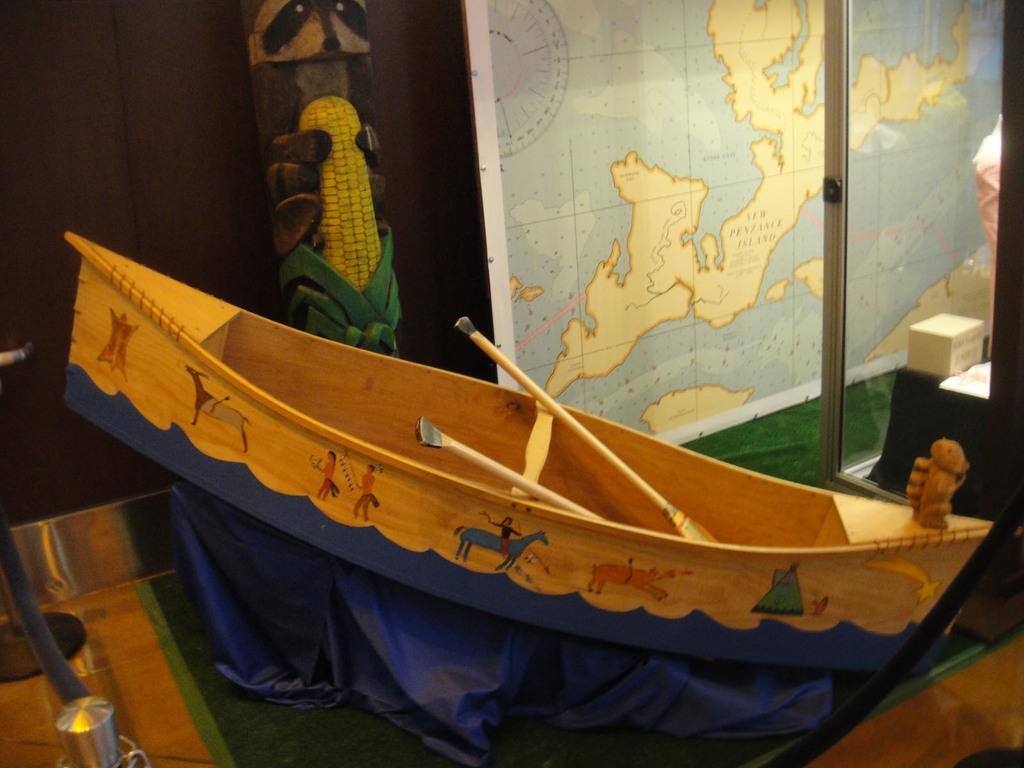What is depicted on the boat in the image? There is a painting on the boat in the image. What objects are used for propulsion in the image? There are paddles in the image. What type of surface is present in the image? There is a board in the image. What navigational tool is visible in the image? There is a map in the image. What architectural feature can be seen in the image? There is a glass door in the image. What type of floor covering is present in the image? There is a carpet in the image. What container is visible in the image? There is a box in the image. What long, thin object is present in the image? There is a rod in the image. What type of barrier or divider is present in the image? There is a wall in the image. What type of bean is being advertised on the boat in the image? There is no bean being advertised in the image; the painting on the boat is not related to beans. What type of appliance can be seen in the image? There is no appliance present in the image. 